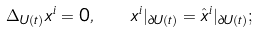Convert formula to latex. <formula><loc_0><loc_0><loc_500><loc_500>\Delta _ { U ( t ) } x ^ { i } = 0 , \ \ x ^ { i } | _ { \partial U ( t ) } = \hat { x } ^ { i } | _ { \partial U ( t ) } ;</formula> 